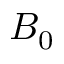<formula> <loc_0><loc_0><loc_500><loc_500>B _ { 0 }</formula> 